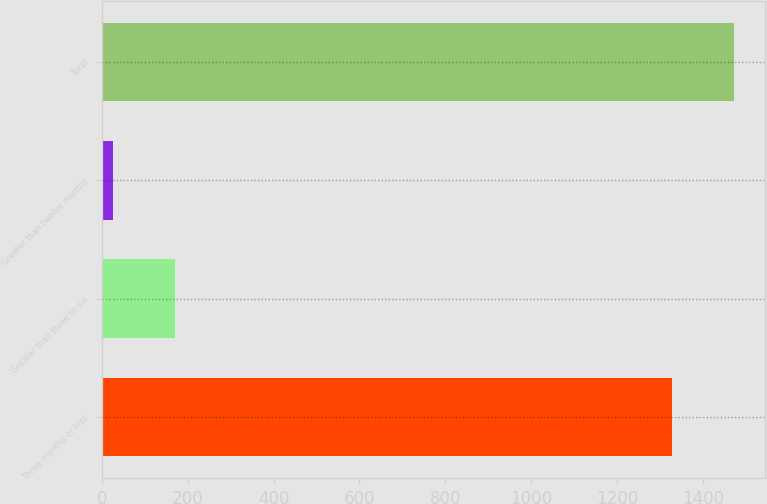<chart> <loc_0><loc_0><loc_500><loc_500><bar_chart><fcel>Three months or less<fcel>Greater than three to six<fcel>Greater than twelve months<fcel>Total<nl><fcel>1327<fcel>169.9<fcel>26<fcel>1470.9<nl></chart> 